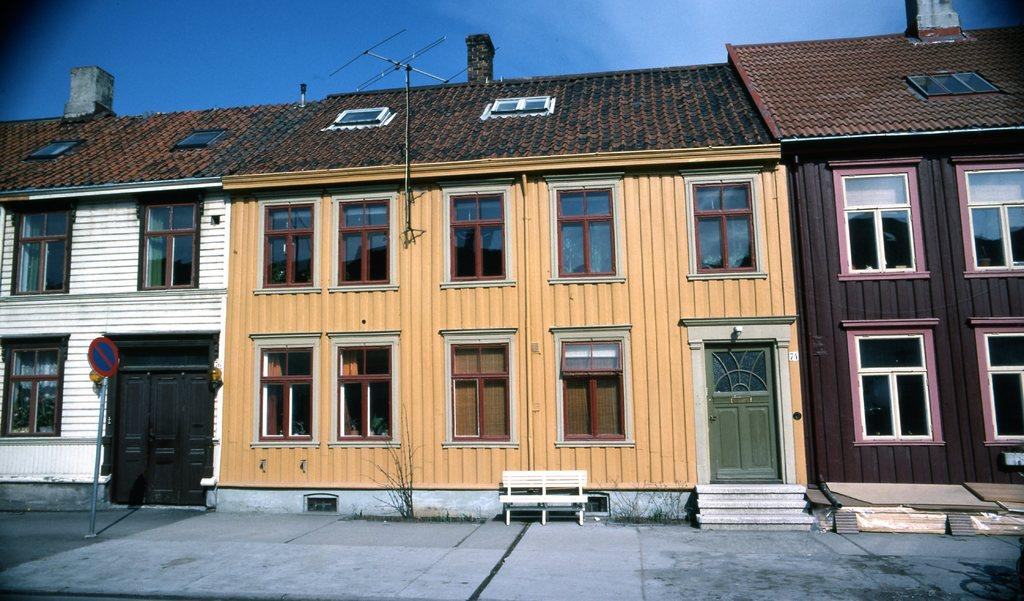What type of structures can be seen in the image? There are buildings in the image. What is located near the buildings? There is a sign board, a bench, stairs, windows, and doors in the image. What is the condition of the sky in the image? The sky is cloudy in the image. What type of oatmeal is being served on the bench in the image? There is no oatmeal or any food item present on the bench in the image. Can you tell me the breed of the pet in the image? There is no pet present in the image. 